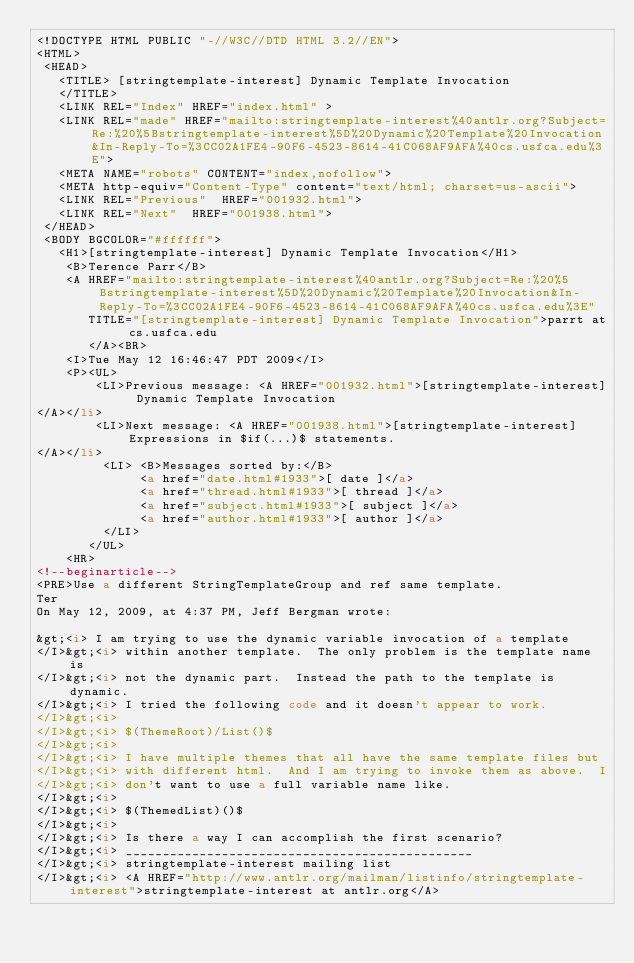<code> <loc_0><loc_0><loc_500><loc_500><_HTML_><!DOCTYPE HTML PUBLIC "-//W3C//DTD HTML 3.2//EN">
<HTML>
 <HEAD>
   <TITLE> [stringtemplate-interest] Dynamic Template Invocation
   </TITLE>
   <LINK REL="Index" HREF="index.html" >
   <LINK REL="made" HREF="mailto:stringtemplate-interest%40antlr.org?Subject=Re:%20%5Bstringtemplate-interest%5D%20Dynamic%20Template%20Invocation&In-Reply-To=%3CC02A1FE4-90F6-4523-8614-41C068AF9AFA%40cs.usfca.edu%3E">
   <META NAME="robots" CONTENT="index,nofollow">
   <META http-equiv="Content-Type" content="text/html; charset=us-ascii">
   <LINK REL="Previous"  HREF="001932.html">
   <LINK REL="Next"  HREF="001938.html">
 </HEAD>
 <BODY BGCOLOR="#ffffff">
   <H1>[stringtemplate-interest] Dynamic Template Invocation</H1>
    <B>Terence Parr</B> 
    <A HREF="mailto:stringtemplate-interest%40antlr.org?Subject=Re:%20%5Bstringtemplate-interest%5D%20Dynamic%20Template%20Invocation&In-Reply-To=%3CC02A1FE4-90F6-4523-8614-41C068AF9AFA%40cs.usfca.edu%3E"
       TITLE="[stringtemplate-interest] Dynamic Template Invocation">parrt at cs.usfca.edu
       </A><BR>
    <I>Tue May 12 16:46:47 PDT 2009</I>
    <P><UL>
        <LI>Previous message: <A HREF="001932.html">[stringtemplate-interest] Dynamic Template Invocation
</A></li>
        <LI>Next message: <A HREF="001938.html">[stringtemplate-interest] Expressions in $if(...)$ statements.
</A></li>
         <LI> <B>Messages sorted by:</B> 
              <a href="date.html#1933">[ date ]</a>
              <a href="thread.html#1933">[ thread ]</a>
              <a href="subject.html#1933">[ subject ]</a>
              <a href="author.html#1933">[ author ]</a>
         </LI>
       </UL>
    <HR>  
<!--beginarticle-->
<PRE>Use a different StringTemplateGroup and ref same template.
Ter
On May 12, 2009, at 4:37 PM, Jeff Bergman wrote:

&gt;<i> I am trying to use the dynamic variable invocation of a template  
</I>&gt;<i> within another template.  The only problem is the template name is  
</I>&gt;<i> not the dynamic part.  Instead the path to the template is dynamic.   
</I>&gt;<i> I tried the following code and it doesn't appear to work.
</I>&gt;<i>
</I>&gt;<i> $(ThemeRoot)/List()$
</I>&gt;<i>
</I>&gt;<i> I have multiple themes that all have the same template files but  
</I>&gt;<i> with different html.  And I am trying to invoke them as above.  I  
</I>&gt;<i> don't want to use a full variable name like.
</I>&gt;<i>
</I>&gt;<i> $(ThemedList)()$
</I>&gt;<i>
</I>&gt;<i> Is there a way I can accomplish the first scenario?  
</I>&gt;<i> _______________________________________________
</I>&gt;<i> stringtemplate-interest mailing list
</I>&gt;<i> <A HREF="http://www.antlr.org/mailman/listinfo/stringtemplate-interest">stringtemplate-interest at antlr.org</A></code> 